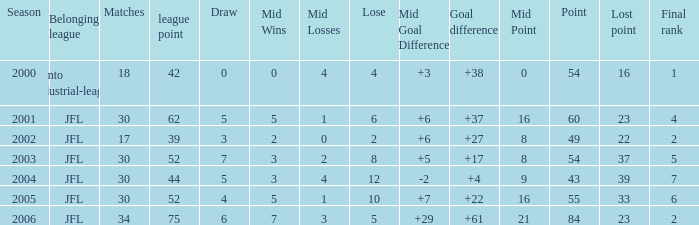Would you mind parsing the complete table? {'header': ['Season', 'Belonging league', 'Matches', 'league point', 'Draw', 'Mid Wins', 'Mid Losses', 'Lose', 'Mid Goal Difference', 'Goal difference', 'Mid Point', 'Point', 'Lost point', 'Final rank'], 'rows': [['2000', 'Kanto industrial-league', '18', '42', '0', '0', '4', '4', '+3', '+38', '0', '54', '16', '1'], ['2001', 'JFL', '30', '62', '5', '5', '1', '6', '+6', '+37', '16', '60', '23', '4'], ['2002', 'JFL', '17', '39', '3', '2', '0', '2', '+6', '+27', '8', '49', '22', '2'], ['2003', 'JFL', '30', '52', '7', '3', '2', '8', '+5', '+17', '8', '54', '37', '5'], ['2004', 'JFL', '30', '44', '5', '3', '4', '12', '-2', '+4', '9', '43', '39', '7'], ['2005', 'JFL', '30', '52', '4', '5', '1', '10', '+7', '+22', '16', '55', '33', '6'], ['2006', 'JFL', '34', '75', '6', '7', '3', '5', '+29', '+61', '21', '84', '23', '2']]} Tell me the highest point with lost point being 33 and league point less than 52 None. 